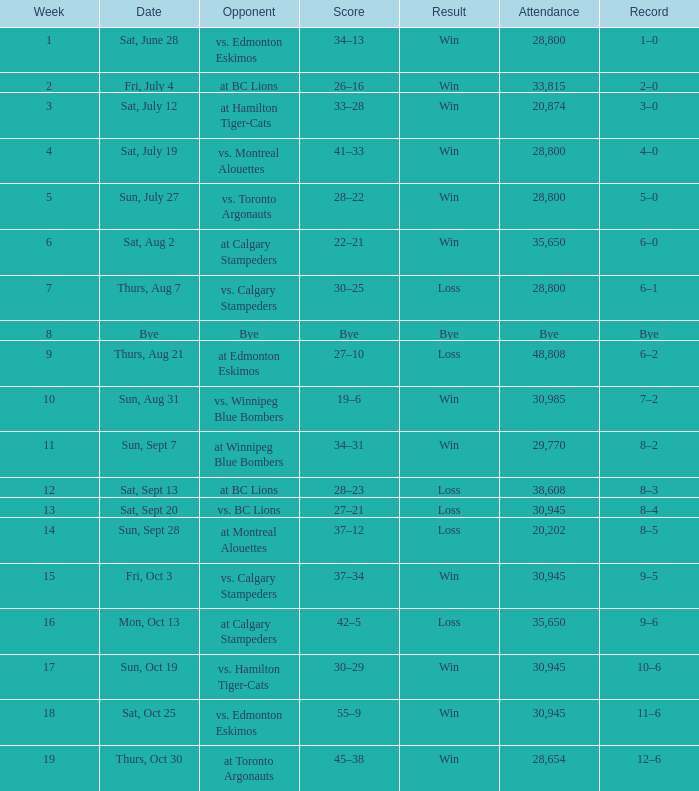What was the standing for the game against calgary stampeders preceding week 15? 6–1. 